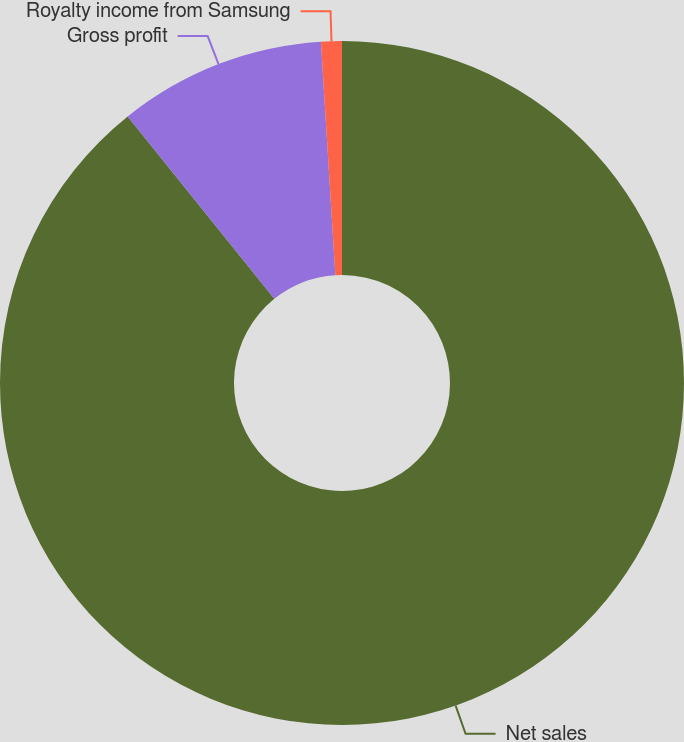<chart> <loc_0><loc_0><loc_500><loc_500><pie_chart><fcel>Net sales<fcel>Gross profit<fcel>Royalty income from Samsung<nl><fcel>89.22%<fcel>9.8%<fcel>0.98%<nl></chart> 